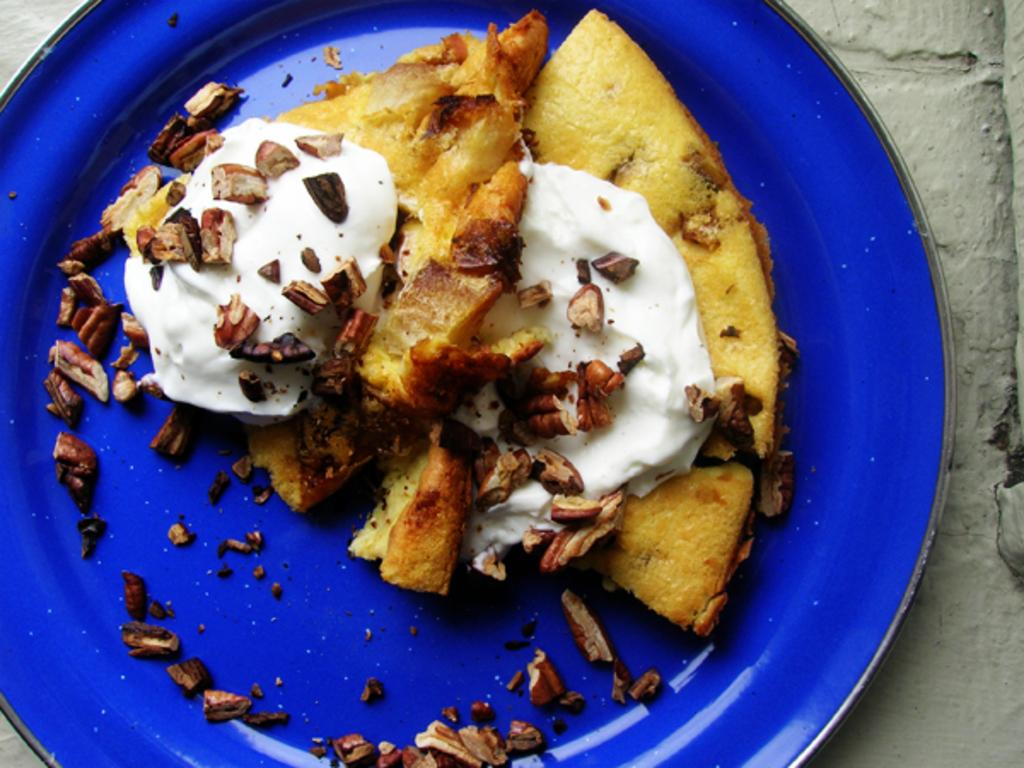What type of food can be seen in the image? There is a food item in the image. What is on top of the food item? The food item is topped with cream. Are there any additional toppings on the food item? Yes, the food item has nuts on it. How is the food item presented in the image? The food item is served on a plate. What role does the parent play in the division of the food item in the image? There is no parent or division of the food item present in the image. What need does the food item fulfill in the image? The image does not provide information about the need that the food item fulfills. 